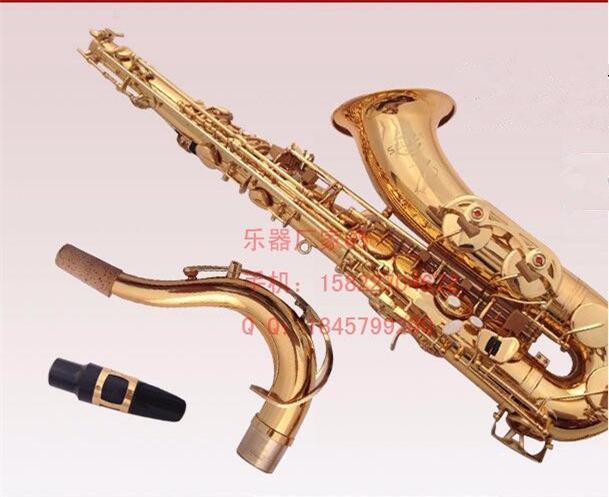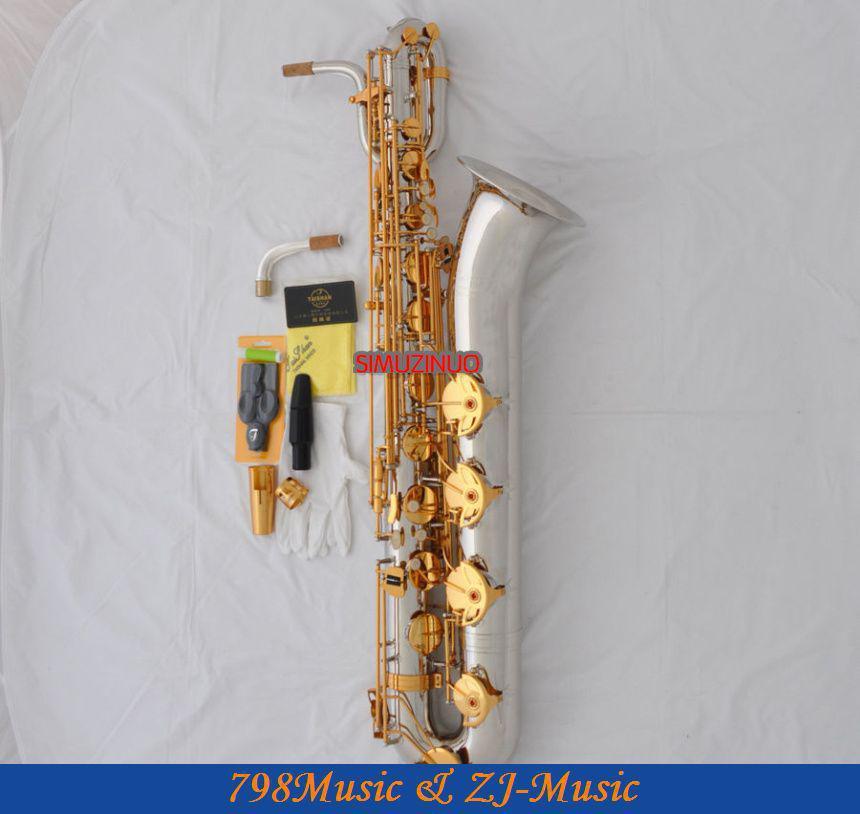The first image is the image on the left, the second image is the image on the right. Evaluate the accuracy of this statement regarding the images: "One image shows only a straight wind instrument, which is brass colored and does not have an upturned bell.". Is it true? Answer yes or no. No. The first image is the image on the left, the second image is the image on the right. Assess this claim about the two images: "There is a saxophone in each image.". Correct or not? Answer yes or no. Yes. 